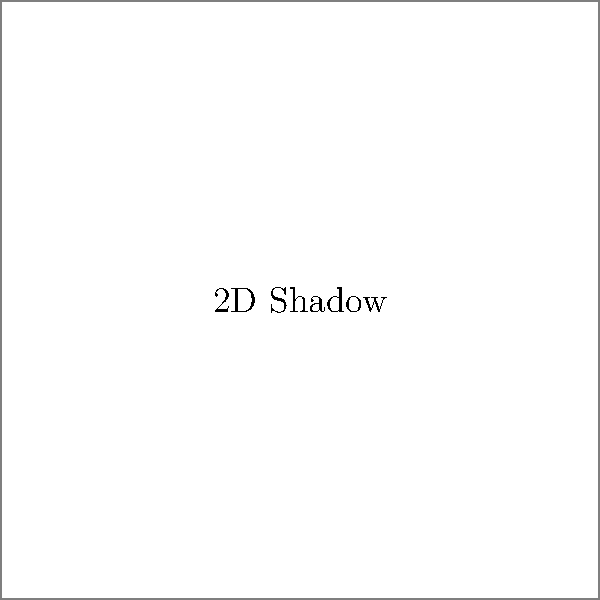Look at the 3D cube and its 2D shadow shown in the image. If the cube were rotated 90 degrees clockwise around its vertical axis, which of the following shapes would best represent its new shadow?

A) A square
B) A rectangle
C) A triangle
D) A circle Let's think about this step-by-step:

1. The current shadow of the cube is a square because we're looking at it from directly above or below.

2. When we rotate the cube 90 degrees clockwise around its vertical axis, we're essentially turning it so that we see a different face.

3. A cube has six identical square faces. No matter how we rotate it, we will always be looking at one of these square faces head-on.

4. When we look at a square face of a cube head-on, its shadow will still be a square.

5. The rotation doesn't change the shape of the shadow; it only potentially changes its size, which isn't a factor in this question.

6. Therefore, even after rotation, the shadow will remain a square.

So, the correct answer is that the new shadow would still be a square.
Answer: A) A square 